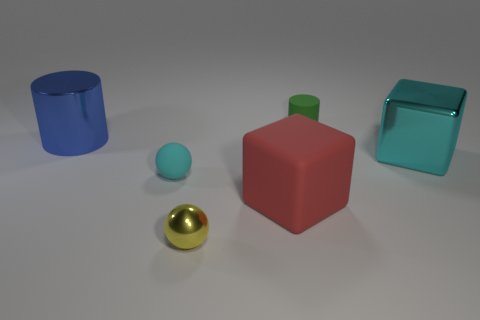Subtract 1 spheres. How many spheres are left? 1 Add 2 cylinders. How many objects exist? 8 Subtract all cyan cubes. How many cubes are left? 1 Subtract all rubber cylinders. Subtract all small purple things. How many objects are left? 5 Add 4 blue cylinders. How many blue cylinders are left? 5 Add 6 small cyan objects. How many small cyan objects exist? 7 Subtract 0 brown cubes. How many objects are left? 6 Subtract all balls. How many objects are left? 4 Subtract all blue balls. Subtract all gray cylinders. How many balls are left? 2 Subtract all green blocks. How many green cylinders are left? 1 